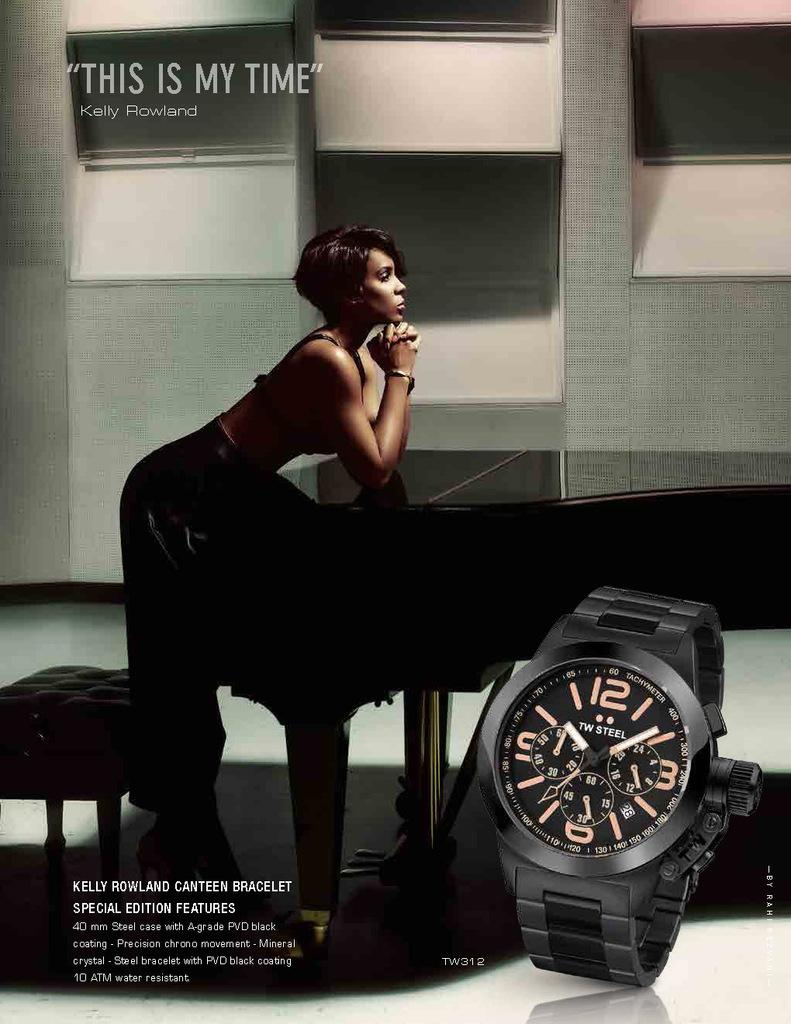<image>
Offer a succinct explanation of the picture presented. A TW steel watch advetisement features Kelly Rowland leaning on a piano. 